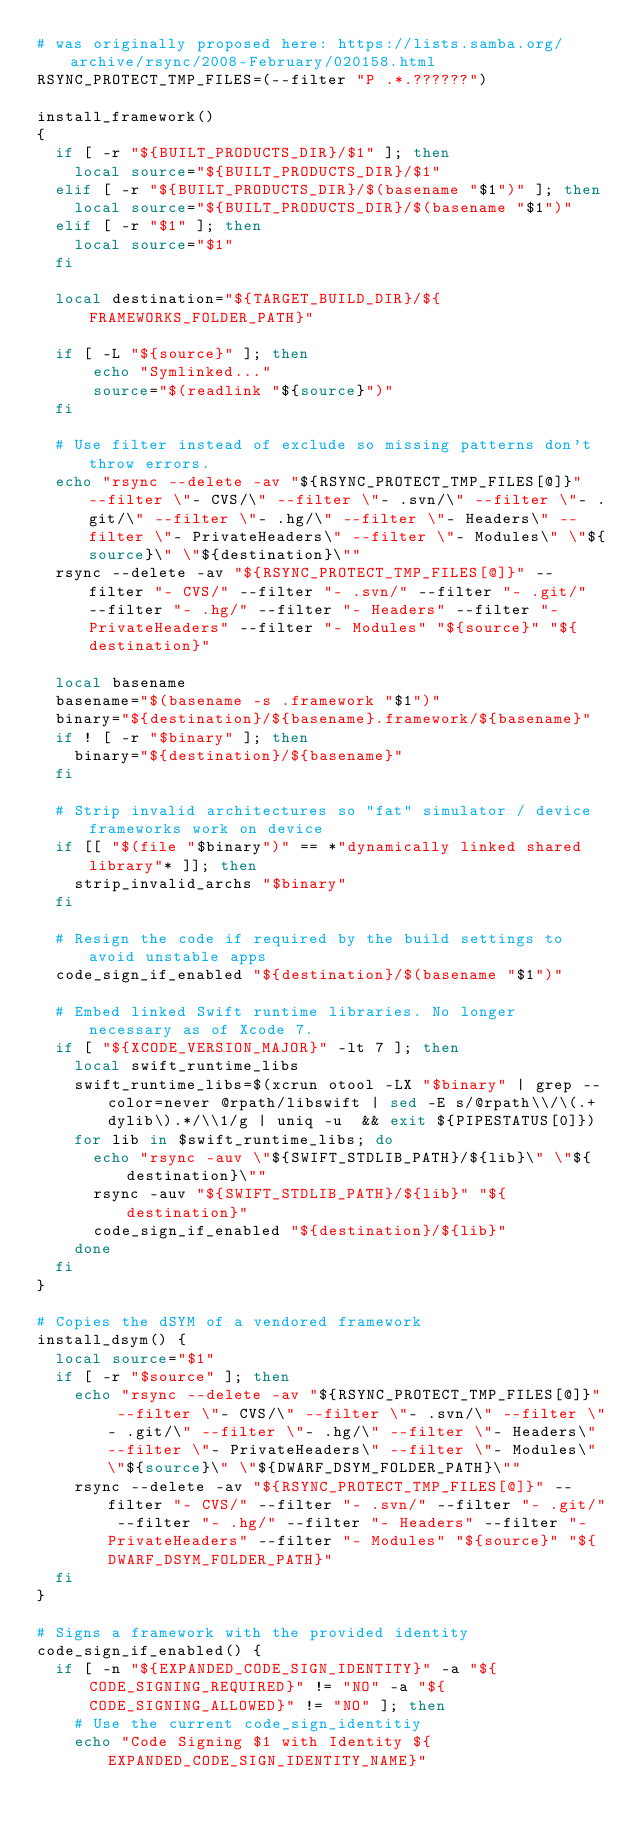Convert code to text. <code><loc_0><loc_0><loc_500><loc_500><_Bash_># was originally proposed here: https://lists.samba.org/archive/rsync/2008-February/020158.html
RSYNC_PROTECT_TMP_FILES=(--filter "P .*.??????")

install_framework()
{
  if [ -r "${BUILT_PRODUCTS_DIR}/$1" ]; then
    local source="${BUILT_PRODUCTS_DIR}/$1"
  elif [ -r "${BUILT_PRODUCTS_DIR}/$(basename "$1")" ]; then
    local source="${BUILT_PRODUCTS_DIR}/$(basename "$1")"
  elif [ -r "$1" ]; then
    local source="$1"
  fi

  local destination="${TARGET_BUILD_DIR}/${FRAMEWORKS_FOLDER_PATH}"

  if [ -L "${source}" ]; then
      echo "Symlinked..."
      source="$(readlink "${source}")"
  fi

  # Use filter instead of exclude so missing patterns don't throw errors.
  echo "rsync --delete -av "${RSYNC_PROTECT_TMP_FILES[@]}" --filter \"- CVS/\" --filter \"- .svn/\" --filter \"- .git/\" --filter \"- .hg/\" --filter \"- Headers\" --filter \"- PrivateHeaders\" --filter \"- Modules\" \"${source}\" \"${destination}\""
  rsync --delete -av "${RSYNC_PROTECT_TMP_FILES[@]}" --filter "- CVS/" --filter "- .svn/" --filter "- .git/" --filter "- .hg/" --filter "- Headers" --filter "- PrivateHeaders" --filter "- Modules" "${source}" "${destination}"

  local basename
  basename="$(basename -s .framework "$1")"
  binary="${destination}/${basename}.framework/${basename}"
  if ! [ -r "$binary" ]; then
    binary="${destination}/${basename}"
  fi

  # Strip invalid architectures so "fat" simulator / device frameworks work on device
  if [[ "$(file "$binary")" == *"dynamically linked shared library"* ]]; then
    strip_invalid_archs "$binary"
  fi

  # Resign the code if required by the build settings to avoid unstable apps
  code_sign_if_enabled "${destination}/$(basename "$1")"

  # Embed linked Swift runtime libraries. No longer necessary as of Xcode 7.
  if [ "${XCODE_VERSION_MAJOR}" -lt 7 ]; then
    local swift_runtime_libs
    swift_runtime_libs=$(xcrun otool -LX "$binary" | grep --color=never @rpath/libswift | sed -E s/@rpath\\/\(.+dylib\).*/\\1/g | uniq -u  && exit ${PIPESTATUS[0]})
    for lib in $swift_runtime_libs; do
      echo "rsync -auv \"${SWIFT_STDLIB_PATH}/${lib}\" \"${destination}\""
      rsync -auv "${SWIFT_STDLIB_PATH}/${lib}" "${destination}"
      code_sign_if_enabled "${destination}/${lib}"
    done
  fi
}

# Copies the dSYM of a vendored framework
install_dsym() {
  local source="$1"
  if [ -r "$source" ]; then
    echo "rsync --delete -av "${RSYNC_PROTECT_TMP_FILES[@]}" --filter \"- CVS/\" --filter \"- .svn/\" --filter \"- .git/\" --filter \"- .hg/\" --filter \"- Headers\" --filter \"- PrivateHeaders\" --filter \"- Modules\" \"${source}\" \"${DWARF_DSYM_FOLDER_PATH}\""
    rsync --delete -av "${RSYNC_PROTECT_TMP_FILES[@]}" --filter "- CVS/" --filter "- .svn/" --filter "- .git/" --filter "- .hg/" --filter "- Headers" --filter "- PrivateHeaders" --filter "- Modules" "${source}" "${DWARF_DSYM_FOLDER_PATH}"
  fi
}

# Signs a framework with the provided identity
code_sign_if_enabled() {
  if [ -n "${EXPANDED_CODE_SIGN_IDENTITY}" -a "${CODE_SIGNING_REQUIRED}" != "NO" -a "${CODE_SIGNING_ALLOWED}" != "NO" ]; then
    # Use the current code_sign_identitiy
    echo "Code Signing $1 with Identity ${EXPANDED_CODE_SIGN_IDENTITY_NAME}"</code> 